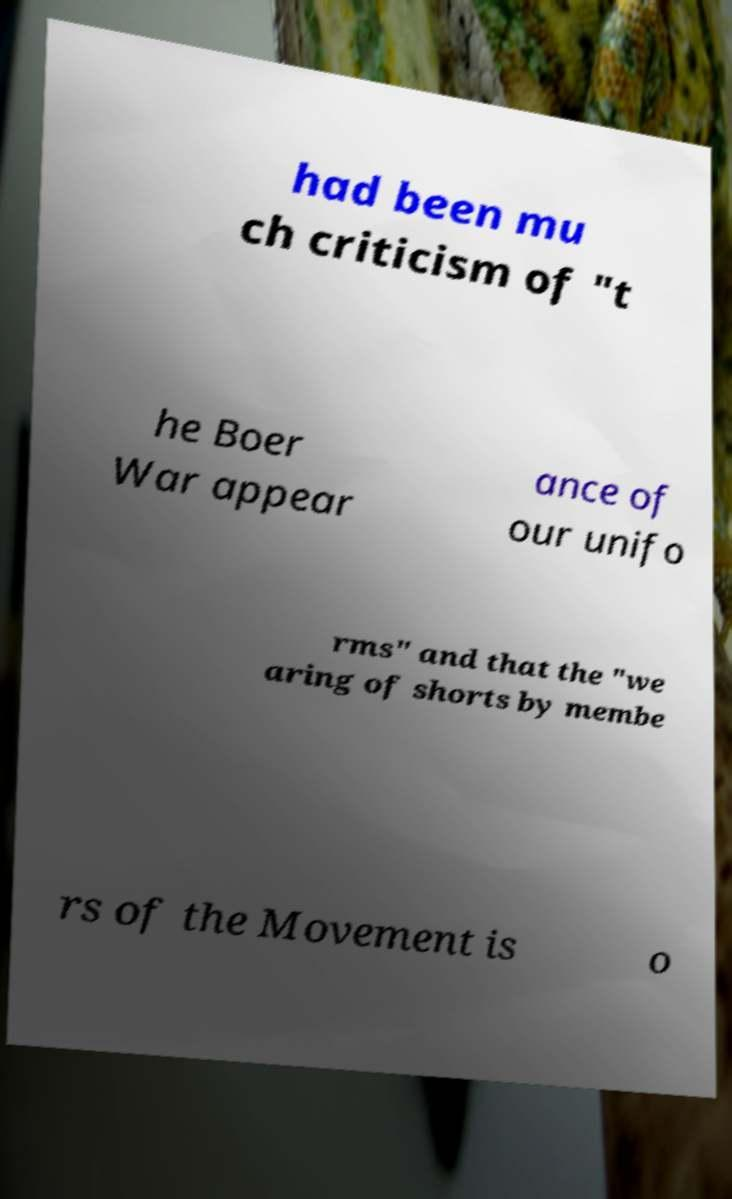Could you extract and type out the text from this image? had been mu ch criticism of "t he Boer War appear ance of our unifo rms" and that the "we aring of shorts by membe rs of the Movement is o 